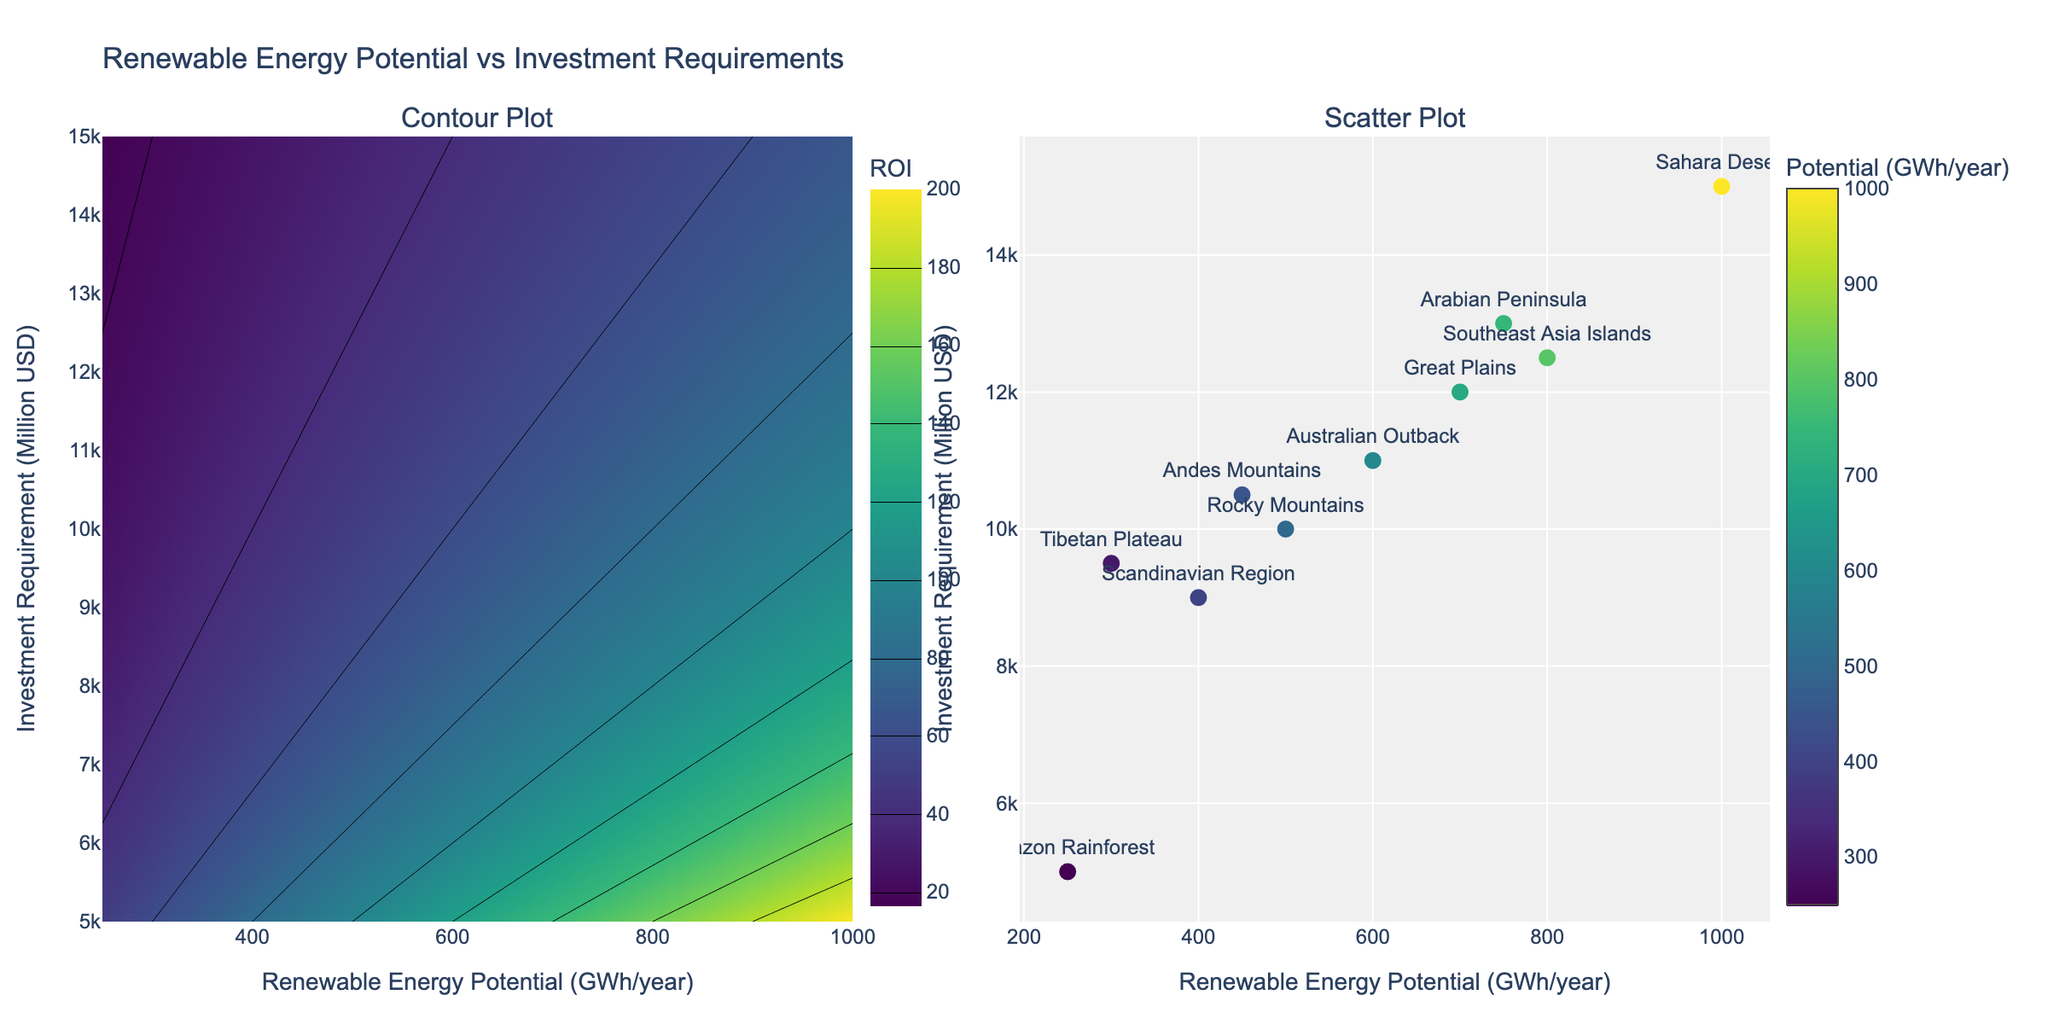How many geographical areas are analyzed in the figure? Count the distinct geographical area labels in the scatter plot on the right subplot. There are 10 unique areas.
Answer: 10 What is the title of the figure? The title is displayed prominently above the subplots. It is "Renewable Energy Potential vs Investment Requirements".
Answer: Renewable Energy Potential vs Investment Requirements What are the ranges of Renewable Energy Potential and Investment Requirement in the scatter plot? Look at the x-axis and y-axis on the scatter plot for their minimum and maximum values. The x-axis ranges from 250 to 1000 GWh/year and the y-axis ranges from 5000 to 15000 Million USD.
Answer: 250-1000 GWh/year, 5000-15000 Million USD How many regions have a Renewable Energy Potential higher than 700 GWh/year? Identify the data points on the scatter plot where the x-value (Renewable Energy Potential) is greater than 700 GWh/year. These regions are Sahara Desert, Arabian Peninsula, and Southeast Asia Islands.
Answer: 3 Which region requires the highest investment? Find the data point with the highest y-value (Investment Requirement) in the scatter plot. The region with the highest investment is the Sahara Desert.
Answer: Sahara Desert What is the ROI (Return on Investment) for the Great Plains, and how is it represented in the contour plot? Using the contours in the left subplot, locate the point corresponding to the Renewable Energy Potential of 700 GWh/year and Investment Requirement of 12000 Million USD. The ROI can be approximated by the Z value at this coordinate, which is around 58. The ROI is represented by different contour levels in varying colors.
Answer: Approximately 58 Which region has the lowest Renewable Energy Potential? Find the data point with the lowest x-value in the scatter plot. The region with the lowest Renewable Energy Potential is the Amazon Rainforest.
Answer: Amazon Rainforest Is there a region that has both high Renewable Energy Potential and high Investment Requirement? Observe the scatter plot for points located in the upper-right area, indicating high values on both axes. The Sahara Desert meets both criteria.
Answer: Sahara Desert Compare the Renewable Energy Potential of the Australian Outback to the Scandinavian Region. Which one is higher? Locate the x-values for both regions in the scatter plot. The Australian Outback has higher Renewable Energy Potential (600 GWh/year) compared to the Scandinavian Region (400 GWh/year).
Answer: Australian Outback 